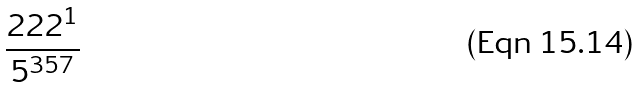<formula> <loc_0><loc_0><loc_500><loc_500>\frac { 2 2 2 ^ { 1 } } { 5 ^ { 3 5 7 } }</formula> 